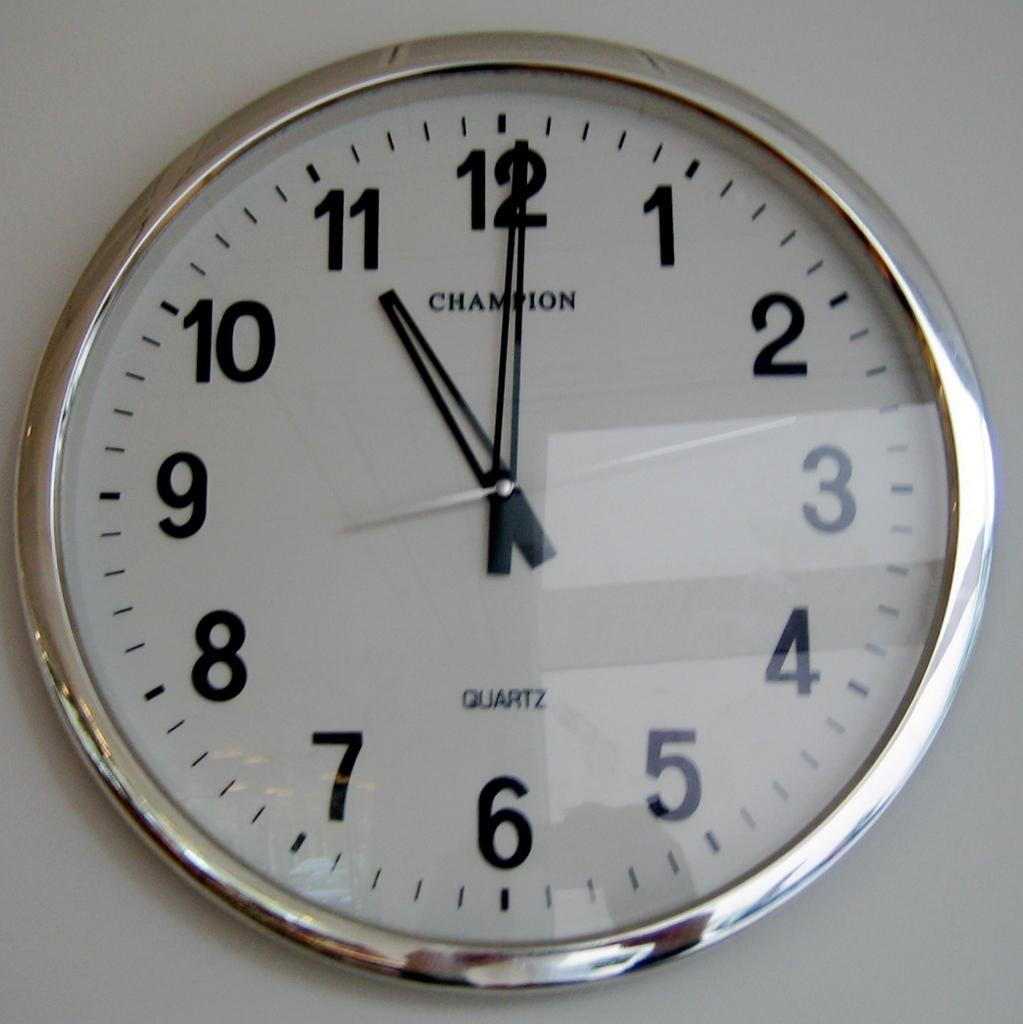Provide a one-sentence caption for the provided image. Wall clock showing 11 o'clock, brand name Champion. 